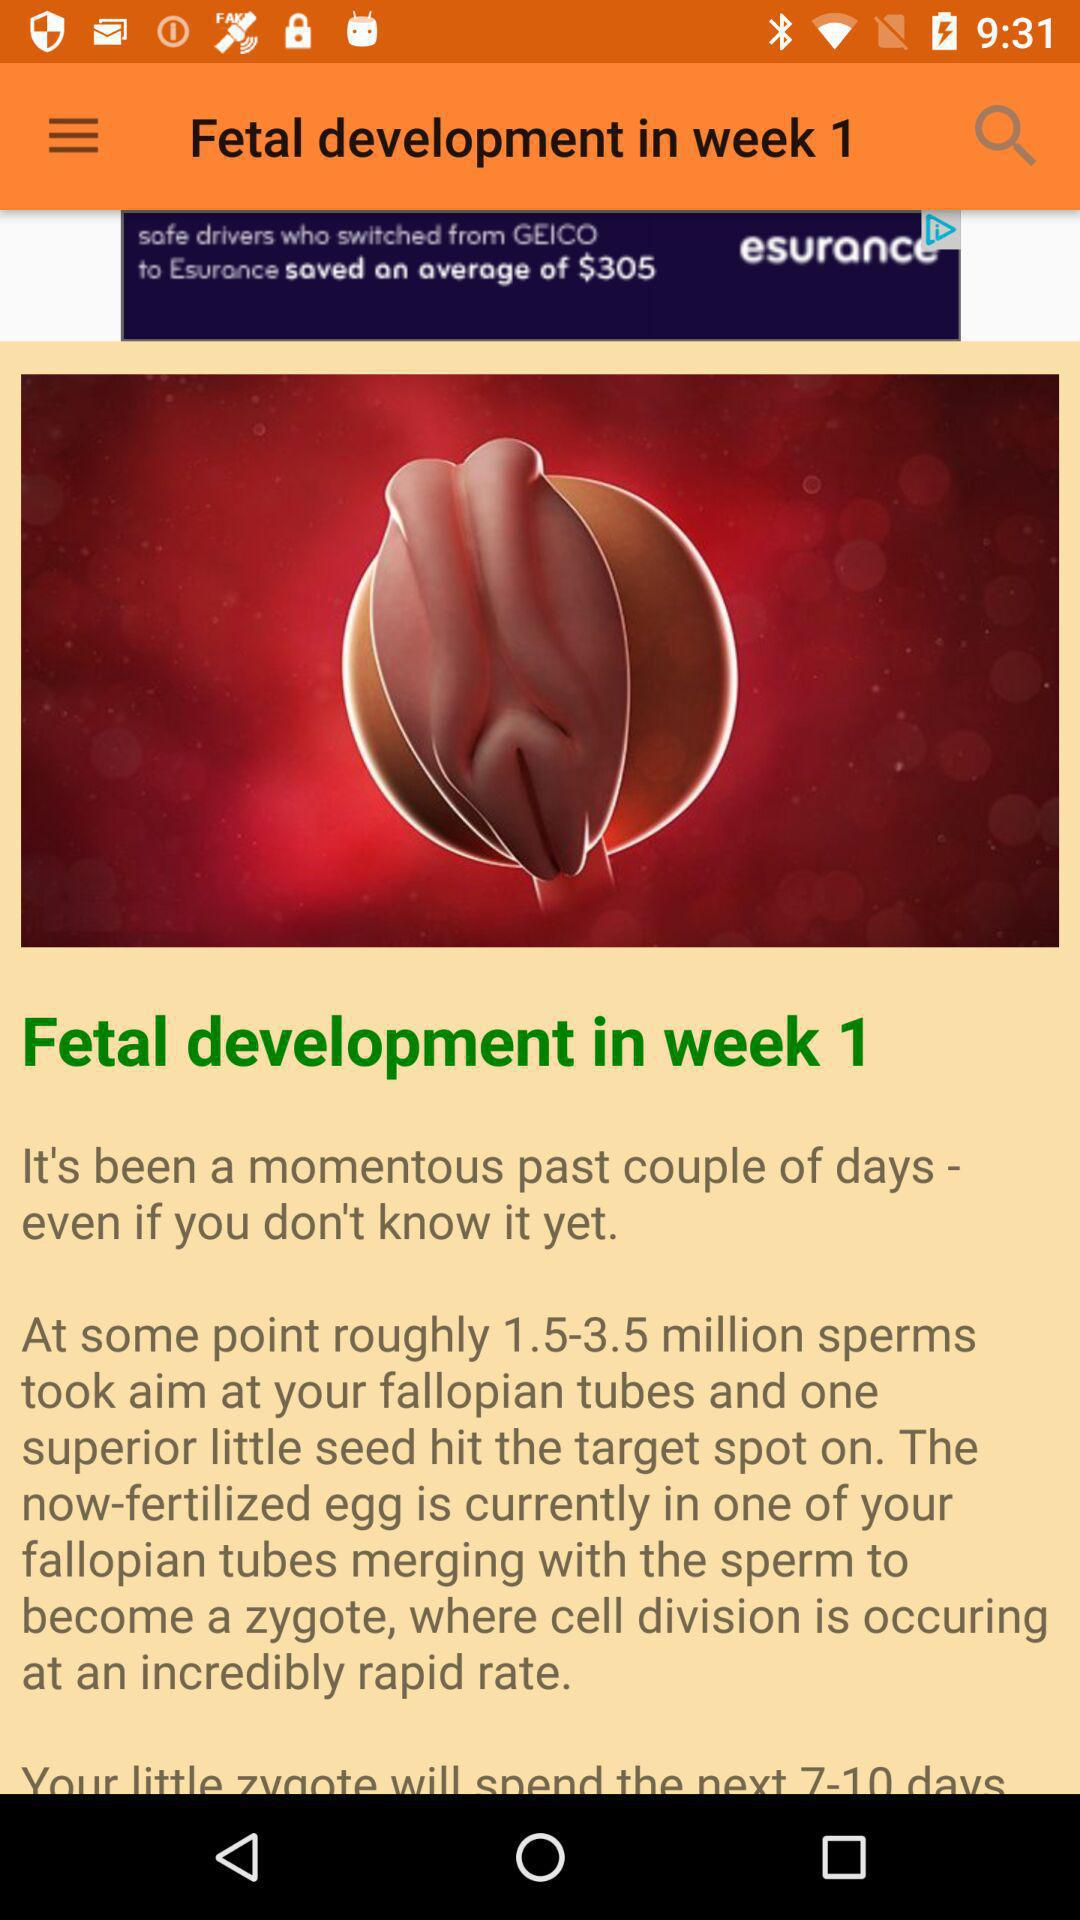How many sperm took aim at the fallopian tube? The number of sperm that took aim at the fallopian tube is roughly 1.5 to 3.5 million. 